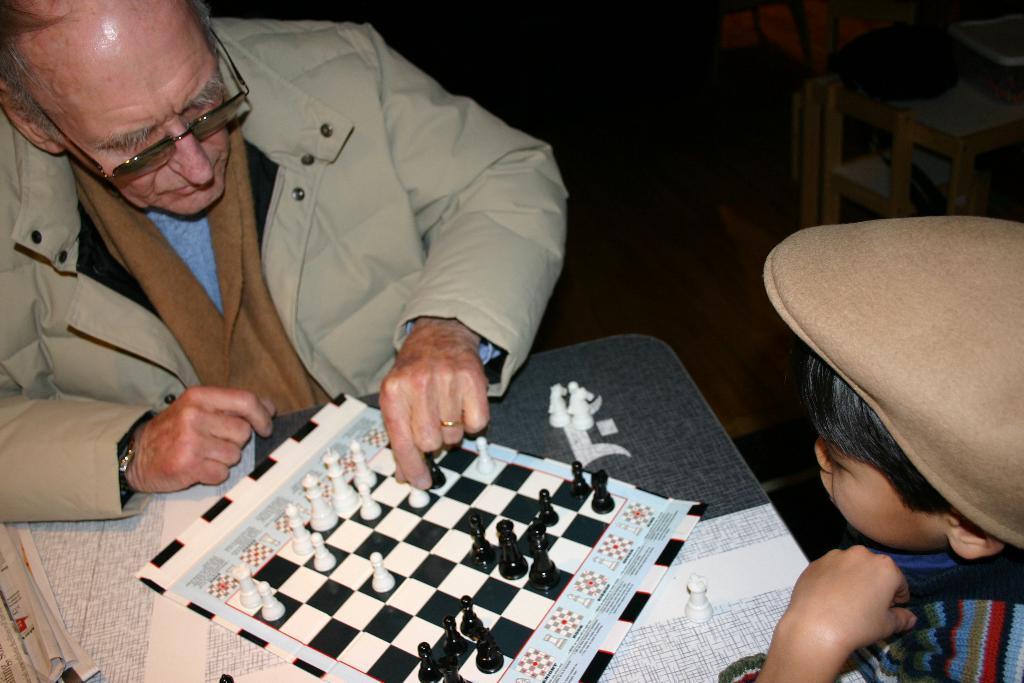Can you describe this image briefly? IN this image there is one man and one boy and boy is wearing a hat and sitting, and in front of them there is a table and it seems that they are playing chess and there is a chess board and coins. And on the left side there are some papers, and in the background there are some objects. 